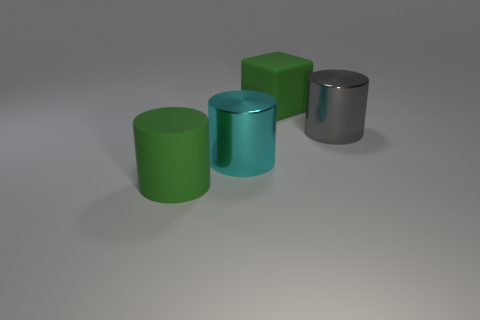What number of cyan metallic objects are left of the big matte object that is to the right of the large rubber object that is in front of the gray metal object?
Ensure brevity in your answer.  1. Is the shape of the big gray object the same as the large matte thing behind the large gray thing?
Make the answer very short. No. The cylinder that is behind the rubber cylinder and in front of the big gray metallic cylinder is what color?
Give a very brief answer. Cyan. There is a large object to the right of the green rubber object on the right side of the green rubber thing that is in front of the large green rubber block; what is its material?
Your answer should be compact. Metal. What material is the big green cylinder?
Keep it short and to the point. Rubber. The gray thing that is the same shape as the large cyan shiny object is what size?
Ensure brevity in your answer.  Large. Do the cube and the big rubber cylinder have the same color?
Offer a terse response. Yes. What number of other objects are there of the same material as the large cyan cylinder?
Your answer should be compact. 1. Is the number of green rubber cylinders that are left of the large green rubber cylinder the same as the number of tiny red rubber spheres?
Offer a terse response. Yes. Does the green matte thing that is behind the cyan object have the same size as the large cyan metallic cylinder?
Offer a very short reply. Yes. 